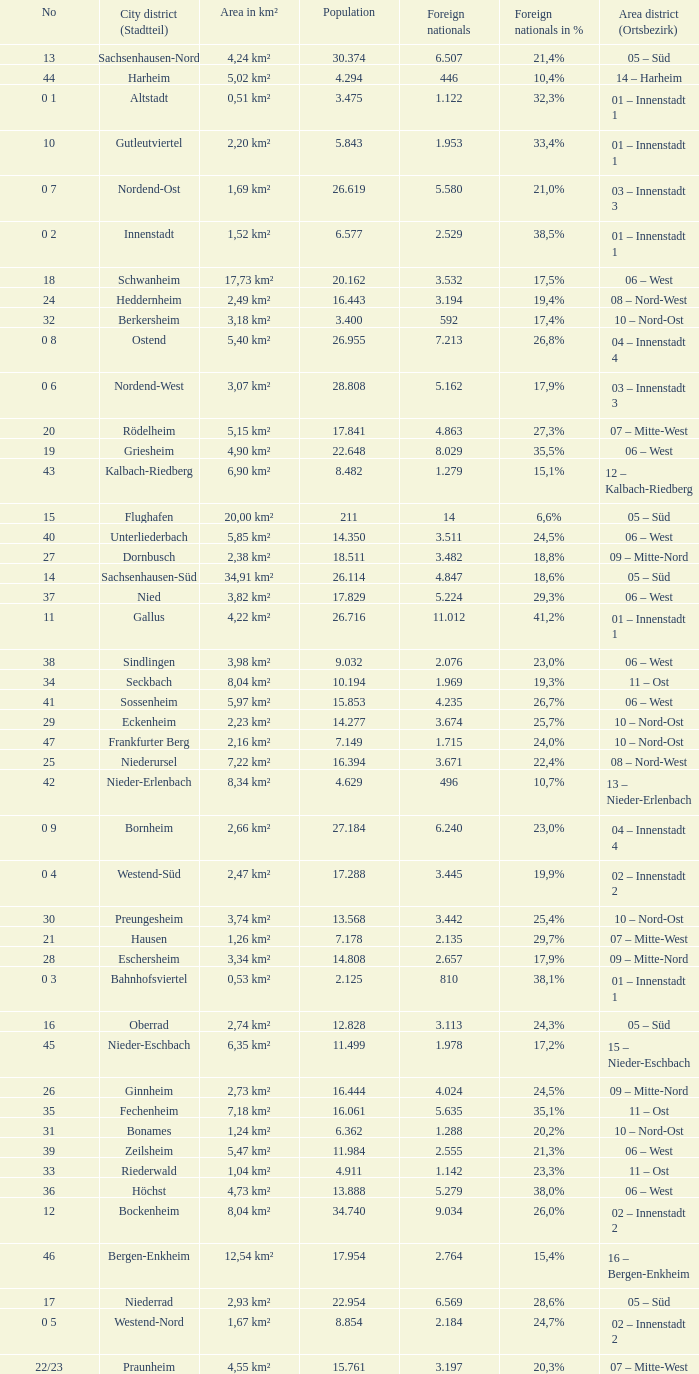What is the city where the number is 47? Frankfurter Berg. 